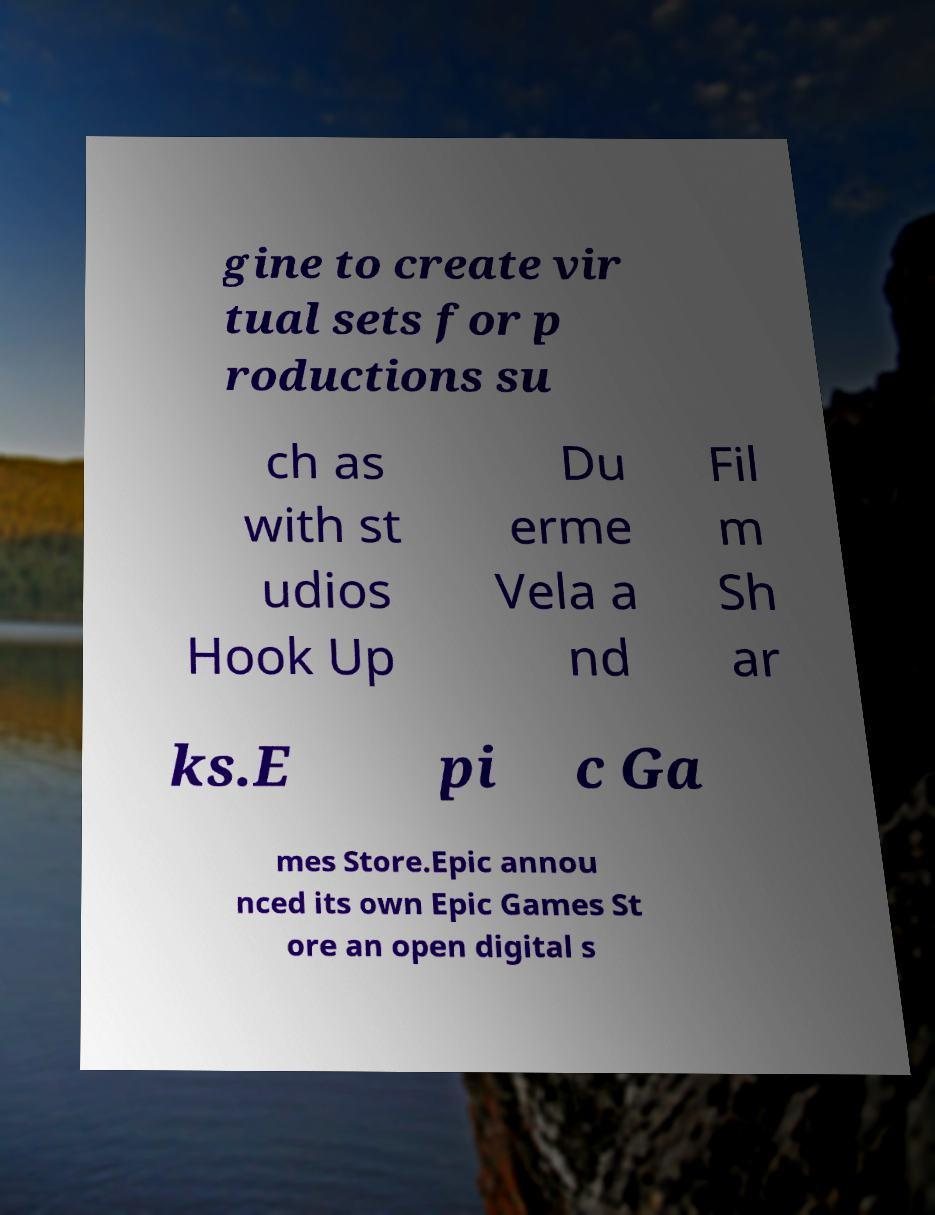Could you assist in decoding the text presented in this image and type it out clearly? gine to create vir tual sets for p roductions su ch as with st udios Hook Up Du erme Vela a nd Fil m Sh ar ks.E pi c Ga mes Store.Epic annou nced its own Epic Games St ore an open digital s 